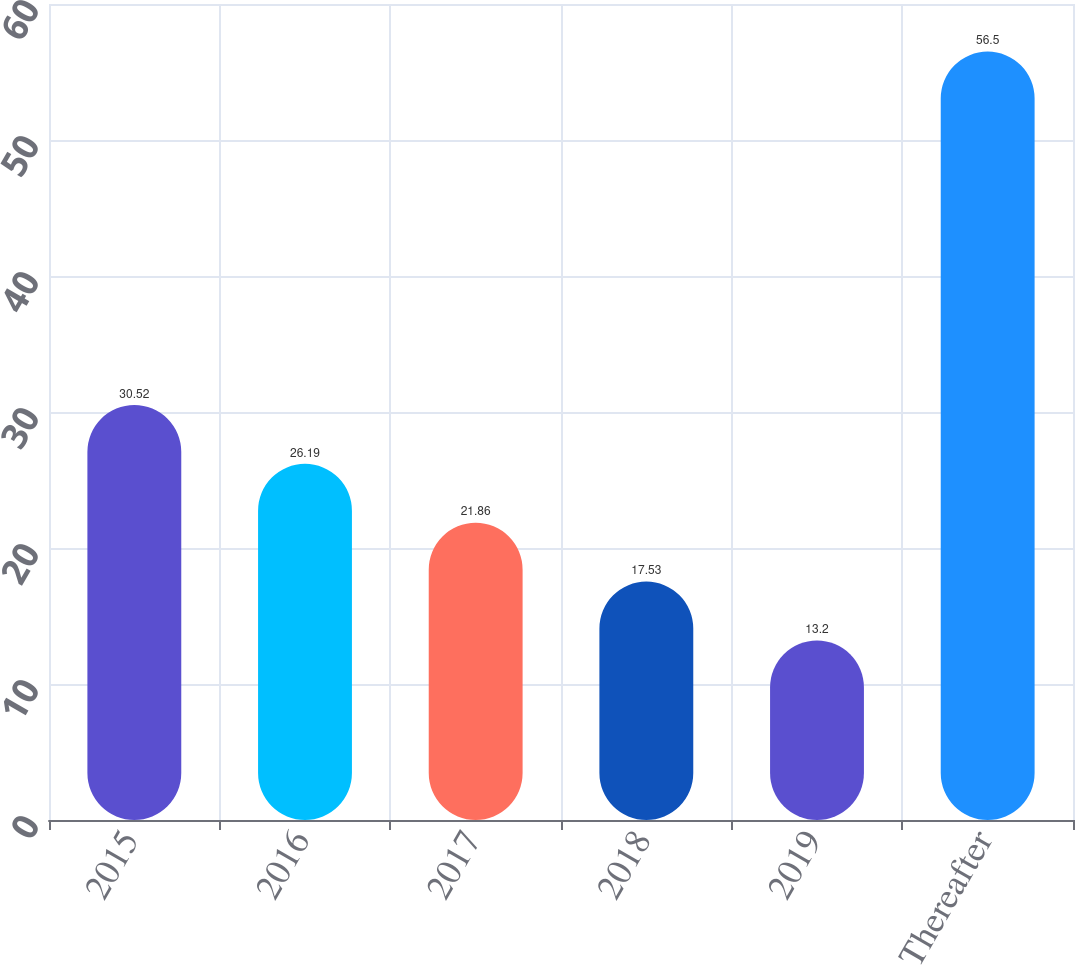Convert chart. <chart><loc_0><loc_0><loc_500><loc_500><bar_chart><fcel>2015<fcel>2016<fcel>2017<fcel>2018<fcel>2019<fcel>Thereafter<nl><fcel>30.52<fcel>26.19<fcel>21.86<fcel>17.53<fcel>13.2<fcel>56.5<nl></chart> 